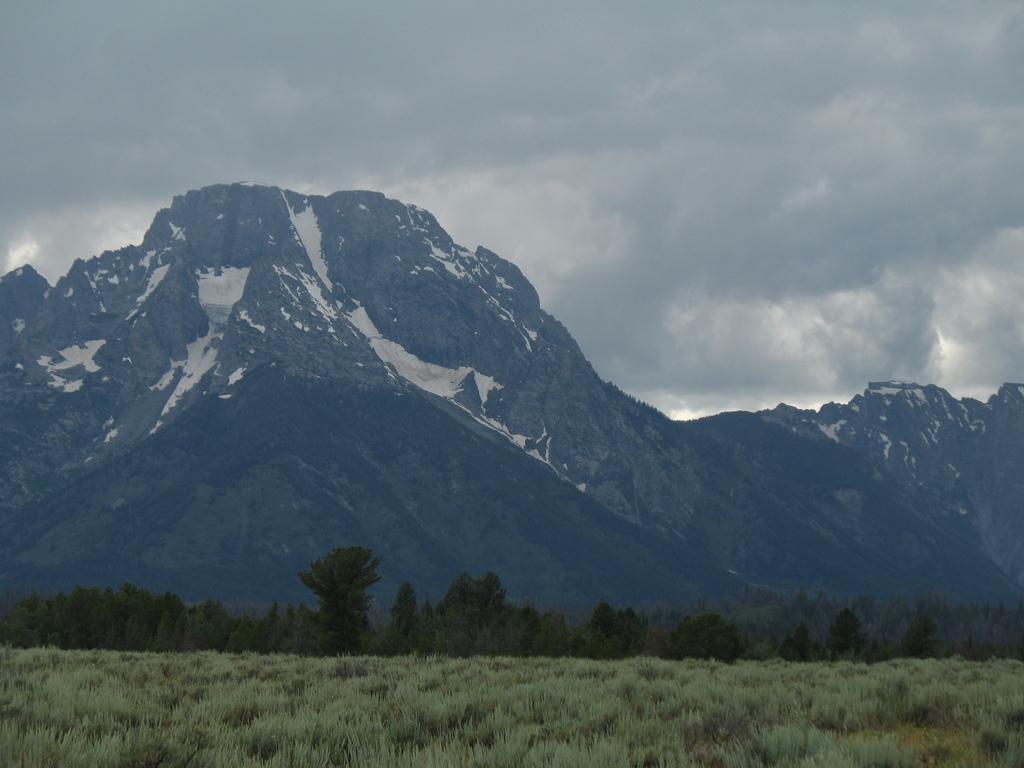How would you summarize this image in a sentence or two? In this picture I can see grass, there are trees, there are snowy mountains, and in the background there is the sky. 